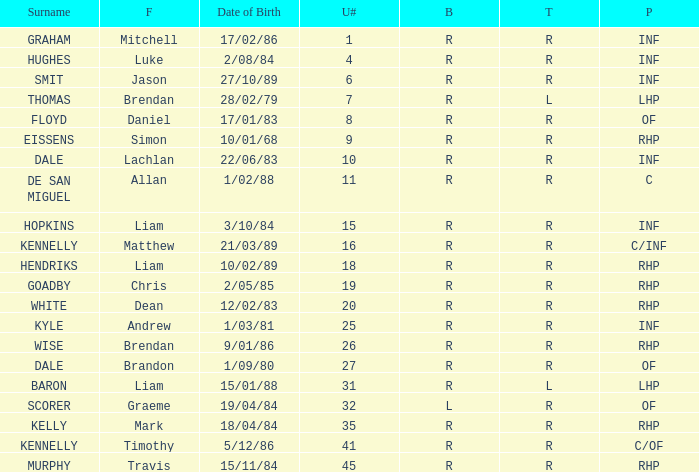Could you parse the entire table? {'header': ['Surname', 'F', 'Date of Birth', 'U#', 'B', 'T', 'P'], 'rows': [['GRAHAM', 'Mitchell', '17/02/86', '1', 'R', 'R', 'INF'], ['HUGHES', 'Luke', '2/08/84', '4', 'R', 'R', 'INF'], ['SMIT', 'Jason', '27/10/89', '6', 'R', 'R', 'INF'], ['THOMAS', 'Brendan', '28/02/79', '7', 'R', 'L', 'LHP'], ['FLOYD', 'Daniel', '17/01/83', '8', 'R', 'R', 'OF'], ['EISSENS', 'Simon', '10/01/68', '9', 'R', 'R', 'RHP'], ['DALE', 'Lachlan', '22/06/83', '10', 'R', 'R', 'INF'], ['DE SAN MIGUEL', 'Allan', '1/02/88', '11', 'R', 'R', 'C'], ['HOPKINS', 'Liam', '3/10/84', '15', 'R', 'R', 'INF'], ['KENNELLY', 'Matthew', '21/03/89', '16', 'R', 'R', 'C/INF'], ['HENDRIKS', 'Liam', '10/02/89', '18', 'R', 'R', 'RHP'], ['GOADBY', 'Chris', '2/05/85', '19', 'R', 'R', 'RHP'], ['WHITE', 'Dean', '12/02/83', '20', 'R', 'R', 'RHP'], ['KYLE', 'Andrew', '1/03/81', '25', 'R', 'R', 'INF'], ['WISE', 'Brendan', '9/01/86', '26', 'R', 'R', 'RHP'], ['DALE', 'Brandon', '1/09/80', '27', 'R', 'R', 'OF'], ['BARON', 'Liam', '15/01/88', '31', 'R', 'L', 'LHP'], ['SCORER', 'Graeme', '19/04/84', '32', 'L', 'R', 'OF'], ['KELLY', 'Mark', '18/04/84', '35', 'R', 'R', 'RHP'], ['KENNELLY', 'Timothy', '5/12/86', '41', 'R', 'R', 'C/OF'], ['MURPHY', 'Travis', '15/11/84', '45', 'R', 'R', 'RHP']]} Which batter has the last name Graham? R. 